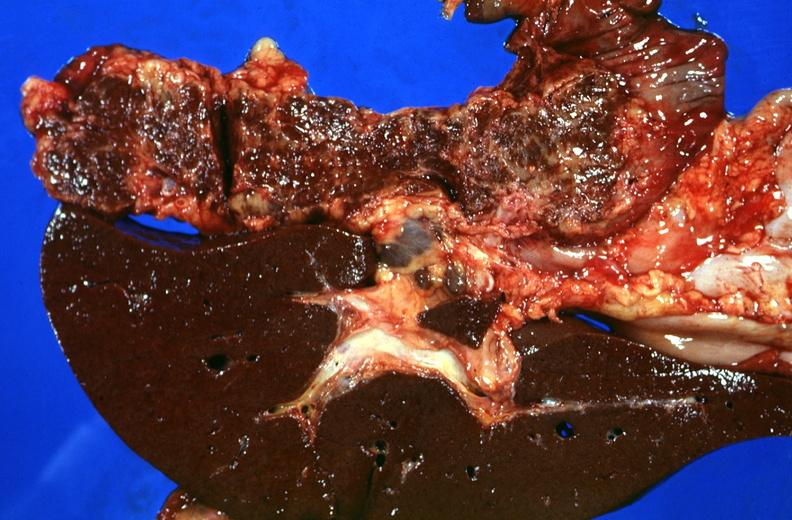does sugar coated show liver and pancreas, hemochromatosis?
Answer the question using a single word or phrase. No 